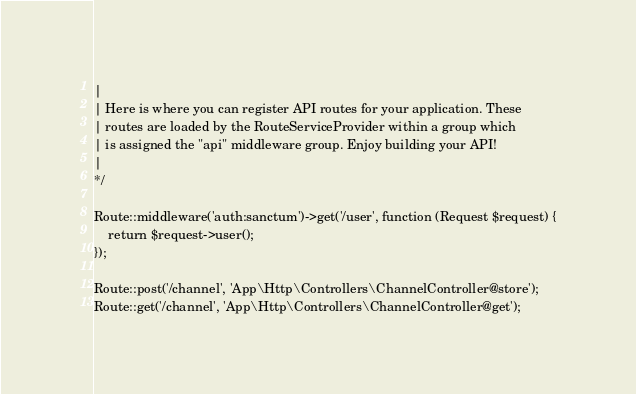Convert code to text. <code><loc_0><loc_0><loc_500><loc_500><_PHP_>|
| Here is where you can register API routes for your application. These
| routes are loaded by the RouteServiceProvider within a group which
| is assigned the "api" middleware group. Enjoy building your API!
|
*/

Route::middleware('auth:sanctum')->get('/user', function (Request $request) {
    return $request->user();
});

Route::post('/channel', 'App\Http\Controllers\ChannelController@store');
Route::get('/channel', 'App\Http\Controllers\ChannelController@get');
</code> 